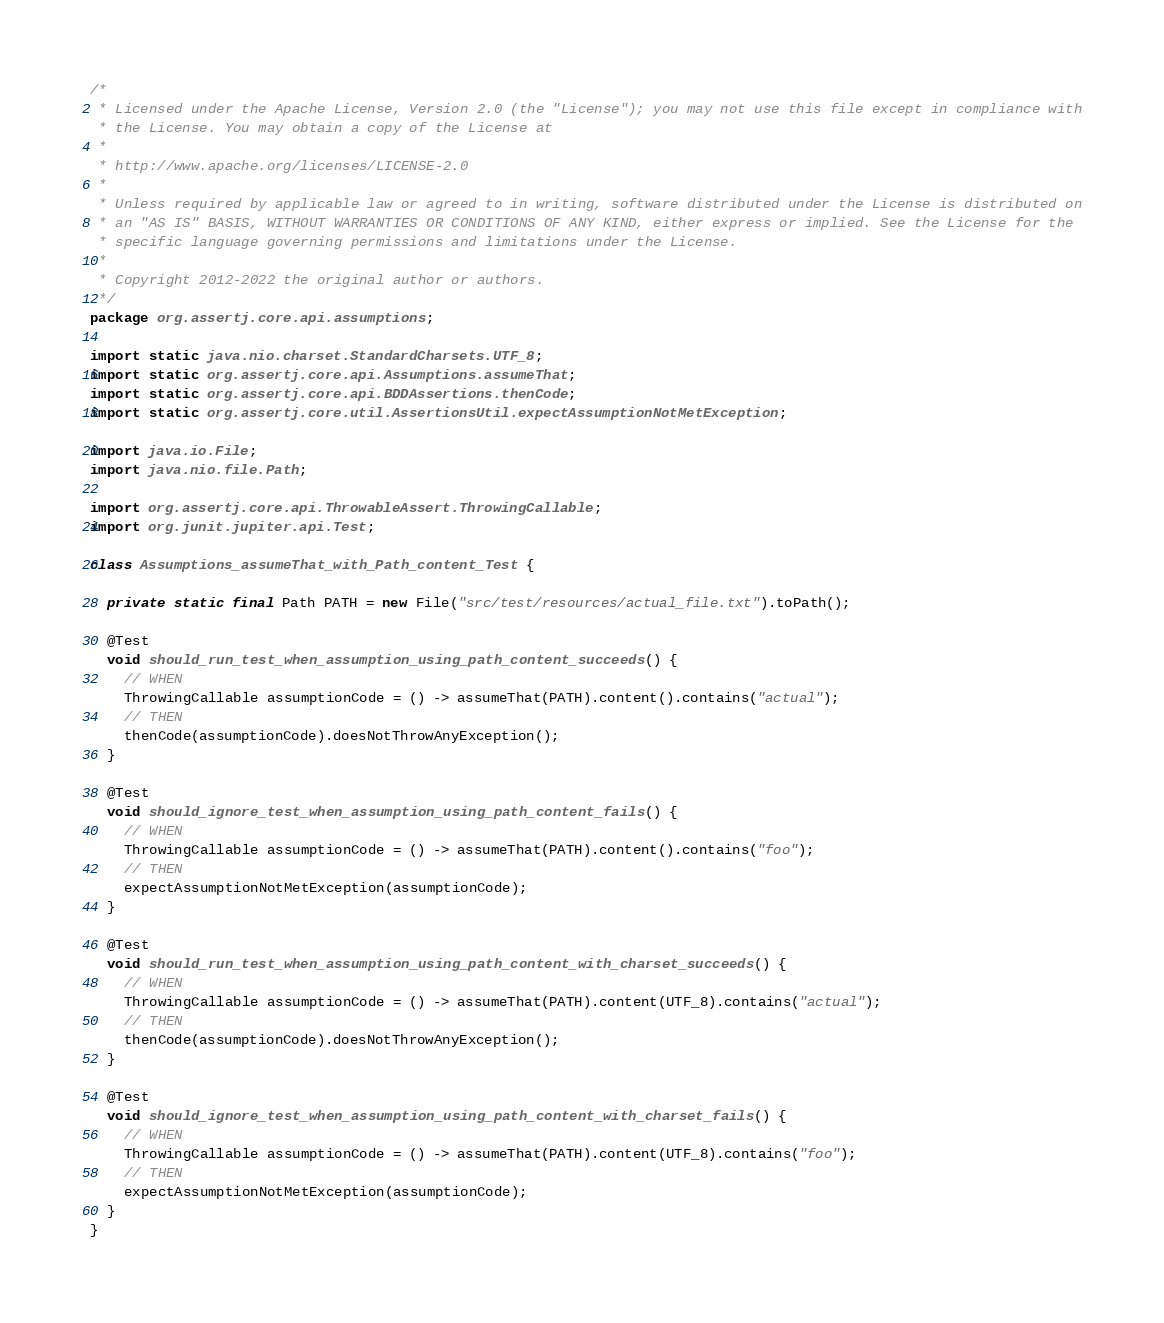Convert code to text. <code><loc_0><loc_0><loc_500><loc_500><_Java_>/*
 * Licensed under the Apache License, Version 2.0 (the "License"); you may not use this file except in compliance with
 * the License. You may obtain a copy of the License at
 *
 * http://www.apache.org/licenses/LICENSE-2.0
 *
 * Unless required by applicable law or agreed to in writing, software distributed under the License is distributed on
 * an "AS IS" BASIS, WITHOUT WARRANTIES OR CONDITIONS OF ANY KIND, either express or implied. See the License for the
 * specific language governing permissions and limitations under the License.
 *
 * Copyright 2012-2022 the original author or authors.
 */
package org.assertj.core.api.assumptions;

import static java.nio.charset.StandardCharsets.UTF_8;
import static org.assertj.core.api.Assumptions.assumeThat;
import static org.assertj.core.api.BDDAssertions.thenCode;
import static org.assertj.core.util.AssertionsUtil.expectAssumptionNotMetException;

import java.io.File;
import java.nio.file.Path;

import org.assertj.core.api.ThrowableAssert.ThrowingCallable;
import org.junit.jupiter.api.Test;

class Assumptions_assumeThat_with_Path_content_Test {

  private static final Path PATH = new File("src/test/resources/actual_file.txt").toPath();

  @Test
  void should_run_test_when_assumption_using_path_content_succeeds() {
    // WHEN
    ThrowingCallable assumptionCode = () -> assumeThat(PATH).content().contains("actual");
    // THEN
    thenCode(assumptionCode).doesNotThrowAnyException();
  }

  @Test
  void should_ignore_test_when_assumption_using_path_content_fails() {
    // WHEN
    ThrowingCallable assumptionCode = () -> assumeThat(PATH).content().contains("foo");
    // THEN
    expectAssumptionNotMetException(assumptionCode);
  }
  
  @Test
  void should_run_test_when_assumption_using_path_content_with_charset_succeeds() {
    // WHEN
    ThrowingCallable assumptionCode = () -> assumeThat(PATH).content(UTF_8).contains("actual");
    // THEN
    thenCode(assumptionCode).doesNotThrowAnyException();
  }
  
  @Test
  void should_ignore_test_when_assumption_using_path_content_with_charset_fails() {
    // WHEN
    ThrowingCallable assumptionCode = () -> assumeThat(PATH).content(UTF_8).contains("foo");
    // THEN
    expectAssumptionNotMetException(assumptionCode);
  }
}
</code> 